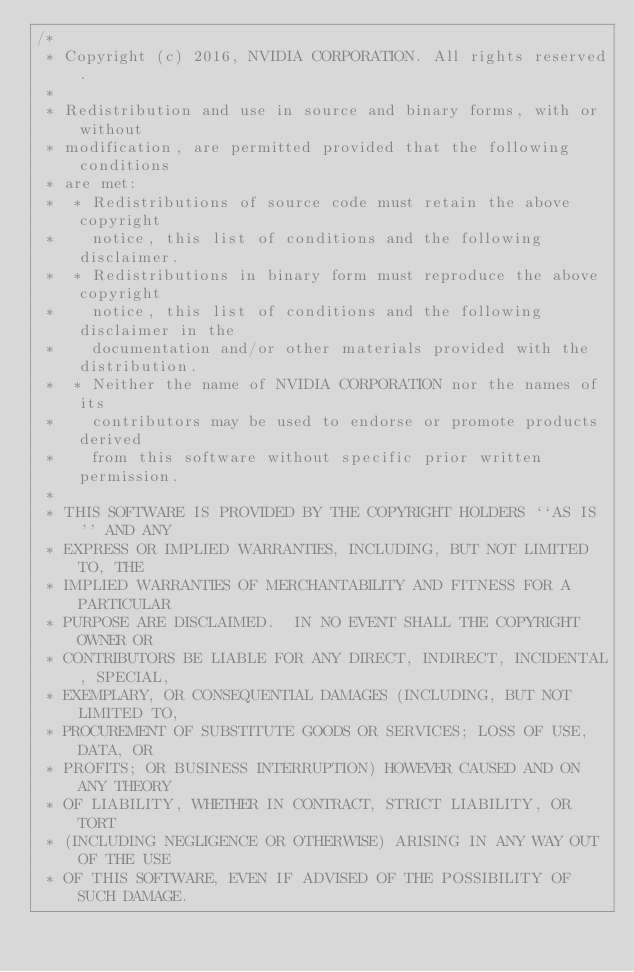Convert code to text. <code><loc_0><loc_0><loc_500><loc_500><_Cuda_>/* 
 * Copyright (c) 2016, NVIDIA CORPORATION. All rights reserved.
 *
 * Redistribution and use in source and binary forms, with or without
 * modification, are permitted provided that the following conditions
 * are met:
 *  * Redistributions of source code must retain the above copyright
 *    notice, this list of conditions and the following disclaimer.
 *  * Redistributions in binary form must reproduce the above copyright
 *    notice, this list of conditions and the following disclaimer in the
 *    documentation and/or other materials provided with the distribution.
 *  * Neither the name of NVIDIA CORPORATION nor the names of its
 *    contributors may be used to endorse or promote products derived
 *    from this software without specific prior written permission.
 *
 * THIS SOFTWARE IS PROVIDED BY THE COPYRIGHT HOLDERS ``AS IS'' AND ANY
 * EXPRESS OR IMPLIED WARRANTIES, INCLUDING, BUT NOT LIMITED TO, THE
 * IMPLIED WARRANTIES OF MERCHANTABILITY AND FITNESS FOR A PARTICULAR
 * PURPOSE ARE DISCLAIMED.  IN NO EVENT SHALL THE COPYRIGHT OWNER OR
 * CONTRIBUTORS BE LIABLE FOR ANY DIRECT, INDIRECT, INCIDENTAL, SPECIAL,
 * EXEMPLARY, OR CONSEQUENTIAL DAMAGES (INCLUDING, BUT NOT LIMITED TO,
 * PROCUREMENT OF SUBSTITUTE GOODS OR SERVICES; LOSS OF USE, DATA, OR
 * PROFITS; OR BUSINESS INTERRUPTION) HOWEVER CAUSED AND ON ANY THEORY
 * OF LIABILITY, WHETHER IN CONTRACT, STRICT LIABILITY, OR TORT
 * (INCLUDING NEGLIGENCE OR OTHERWISE) ARISING IN ANY WAY OUT OF THE USE
 * OF THIS SOFTWARE, EVEN IF ADVISED OF THE POSSIBILITY OF SUCH DAMAGE.</code> 